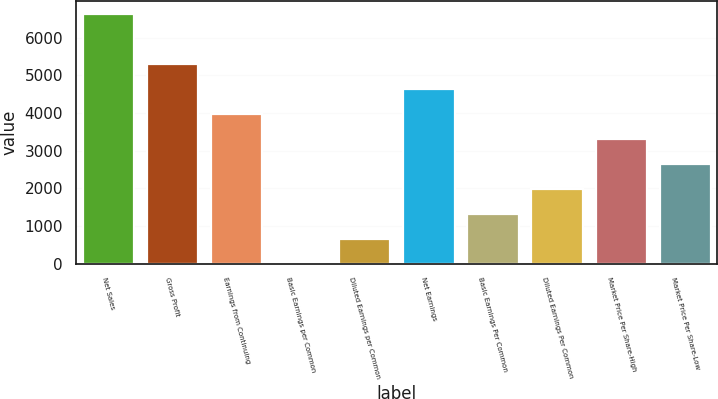Convert chart. <chart><loc_0><loc_0><loc_500><loc_500><bar_chart><fcel>Net Sales<fcel>Gross Profit<fcel>Earnings from Continuing<fcel>Basic Earnings per Common<fcel>Diluted Earnings per Common<fcel>Net Earnings<fcel>Basic Earnings Per Common<fcel>Diluted Earnings Per Common<fcel>Market Price Per Share-High<fcel>Market Price Per Share-Low<nl><fcel>6637<fcel>5309.66<fcel>3982.28<fcel>0.15<fcel>663.84<fcel>4645.97<fcel>1327.53<fcel>1991.22<fcel>3318.59<fcel>2654.91<nl></chart> 